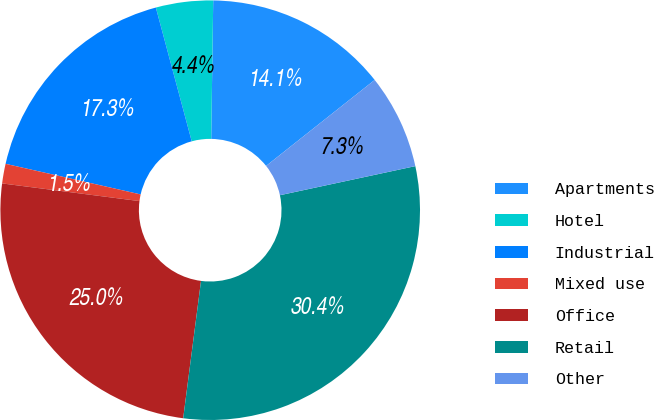Convert chart. <chart><loc_0><loc_0><loc_500><loc_500><pie_chart><fcel>Apartments<fcel>Hotel<fcel>Industrial<fcel>Mixed use<fcel>Office<fcel>Retail<fcel>Other<nl><fcel>14.11%<fcel>4.4%<fcel>17.28%<fcel>1.51%<fcel>24.98%<fcel>30.42%<fcel>7.29%<nl></chart> 